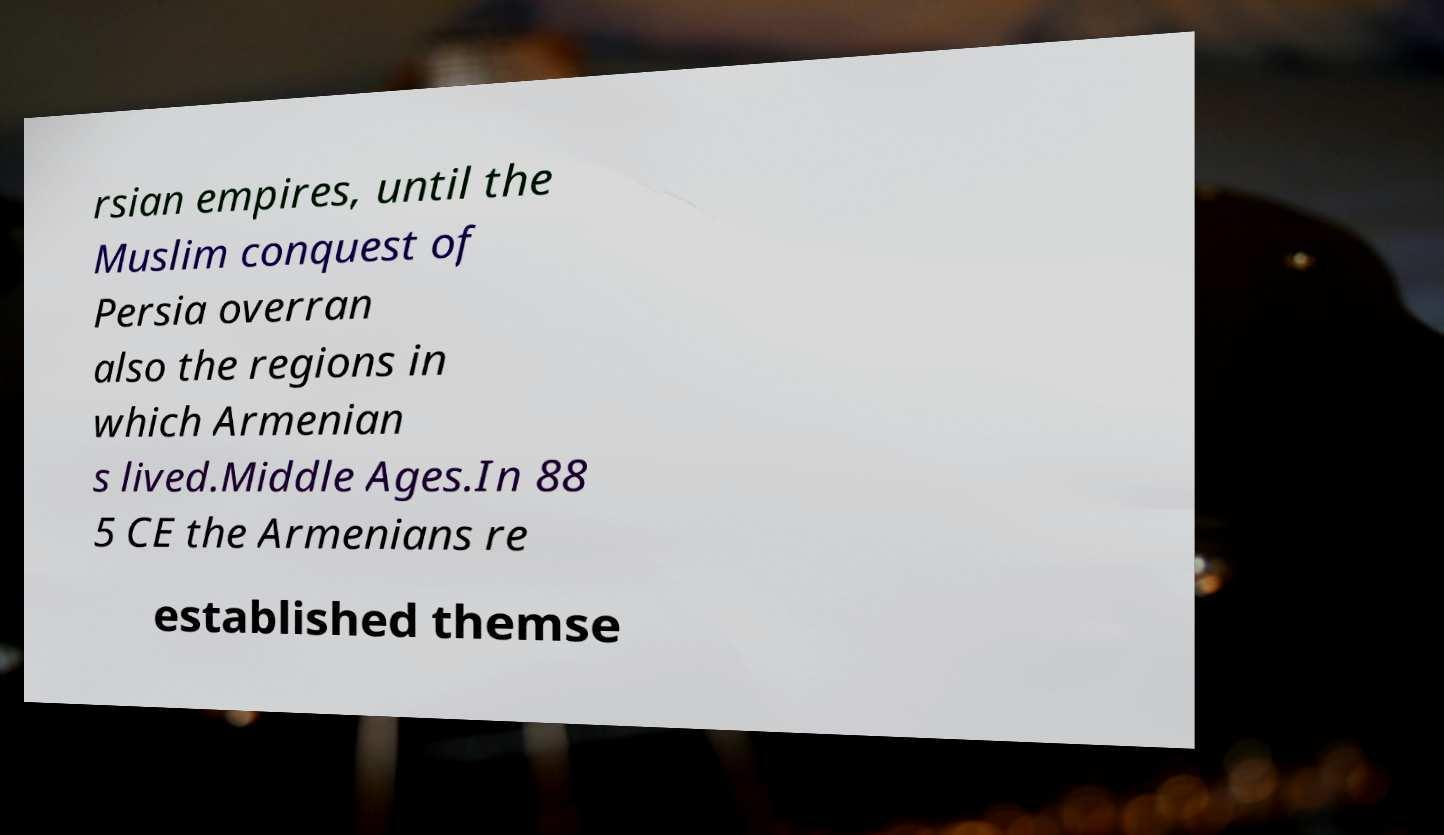There's text embedded in this image that I need extracted. Can you transcribe it verbatim? rsian empires, until the Muslim conquest of Persia overran also the regions in which Armenian s lived.Middle Ages.In 88 5 CE the Armenians re established themse 